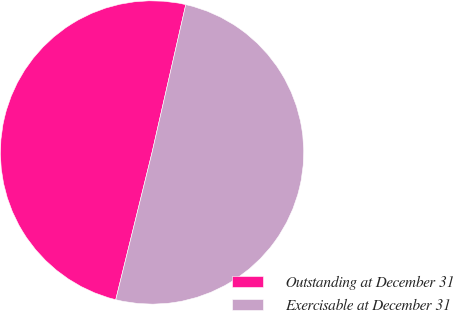Convert chart. <chart><loc_0><loc_0><loc_500><loc_500><pie_chart><fcel>Outstanding at December 31<fcel>Exercisable at December 31<nl><fcel>49.72%<fcel>50.28%<nl></chart> 